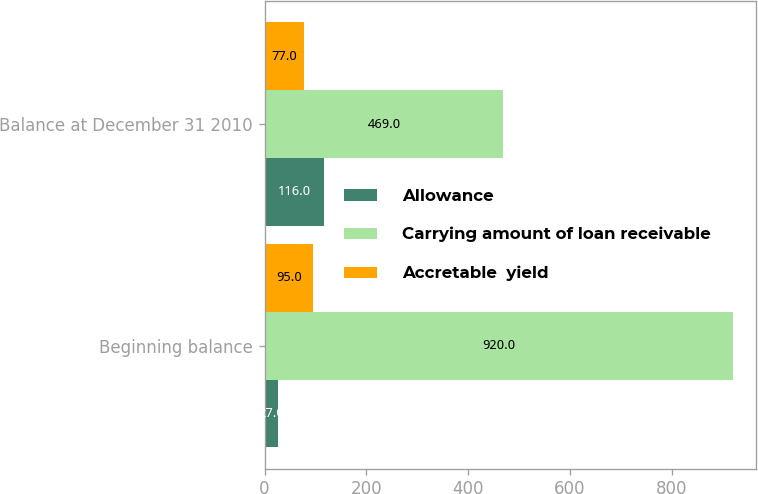Convert chart to OTSL. <chart><loc_0><loc_0><loc_500><loc_500><stacked_bar_chart><ecel><fcel>Beginning balance<fcel>Balance at December 31 2010<nl><fcel>Allowance<fcel>27<fcel>116<nl><fcel>Carrying amount of loan receivable<fcel>920<fcel>469<nl><fcel>Accretable  yield<fcel>95<fcel>77<nl></chart> 